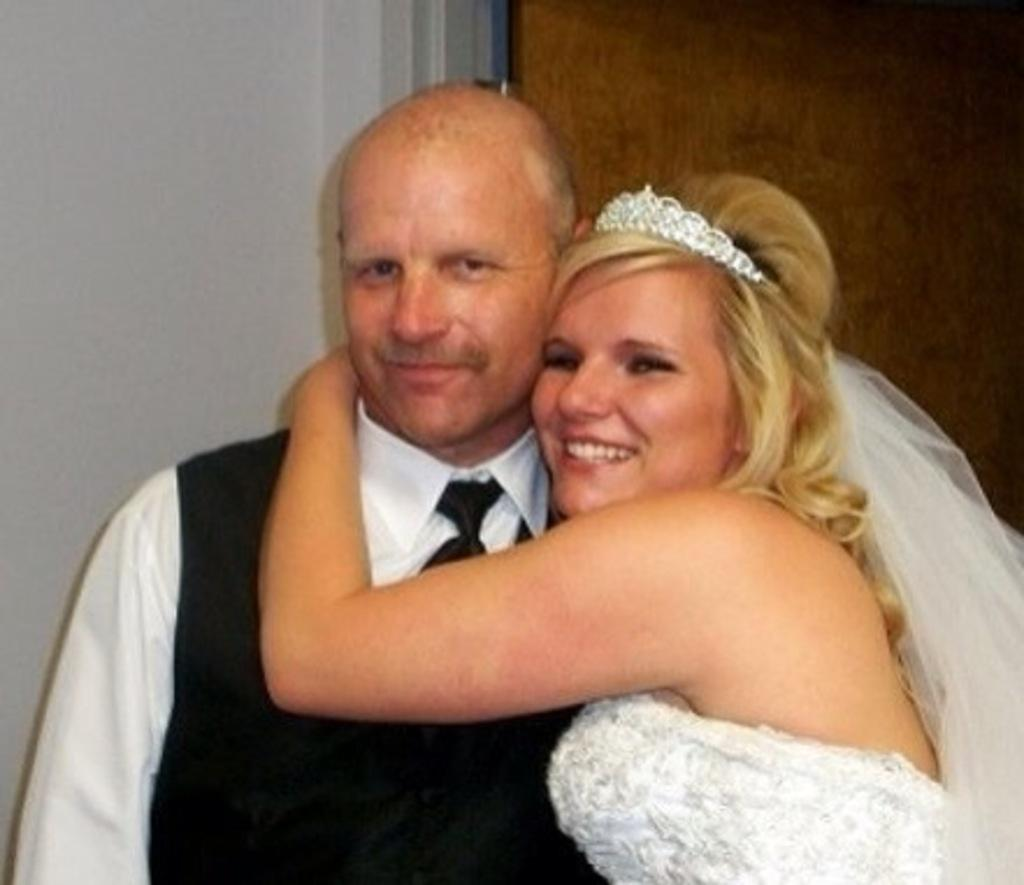How many people are in the image? There are two people standing in the image. What are the people wearing? Both people are wearing black and white color dresses. Can you describe any distinguishing features of the people? One person is wearing a white color crown. What can be seen in the background of the image? There is a white wall visible in the background of the image. Is there a river flowing in the image? There is no river visible in the image. 